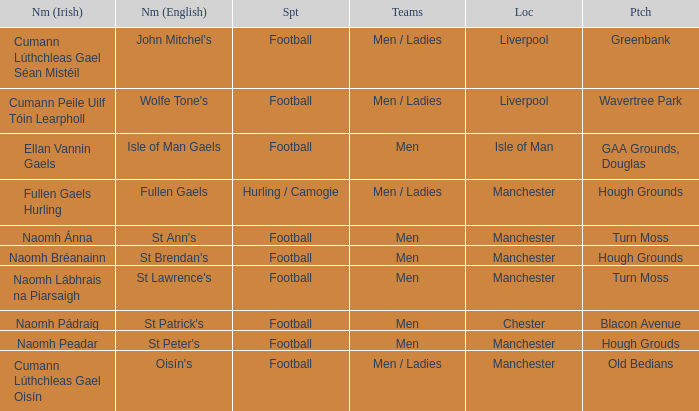What is the Location of the Old Bedians Pitch? Manchester. 